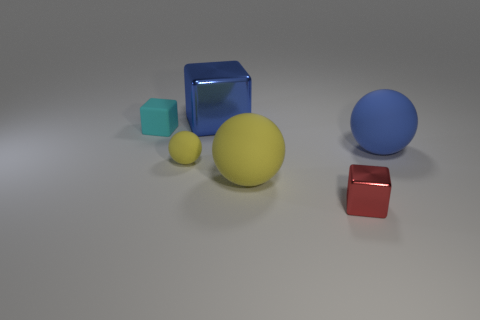Subtract 1 spheres. How many spheres are left? 2 Add 1 small red blocks. How many objects exist? 7 Subtract all large gray metallic cylinders. Subtract all large yellow objects. How many objects are left? 5 Add 1 small things. How many small things are left? 4 Add 6 cyan objects. How many cyan objects exist? 7 Subtract 0 cyan spheres. How many objects are left? 6 